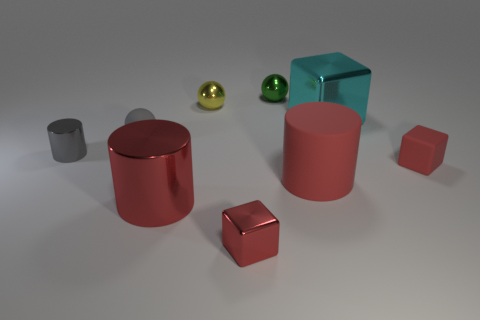Add 1 large cyan metallic things. How many objects exist? 10 Subtract 1 cylinders. How many cylinders are left? 2 Subtract all large cylinders. How many cylinders are left? 1 Subtract all gray spheres. Subtract all red blocks. How many spheres are left? 2 Subtract all cyan blocks. How many blocks are left? 2 Subtract all cylinders. How many objects are left? 6 Subtract all cyan blocks. How many gray cylinders are left? 1 Subtract all purple shiny cubes. Subtract all green objects. How many objects are left? 8 Add 6 cyan shiny things. How many cyan shiny things are left? 7 Add 4 green objects. How many green objects exist? 5 